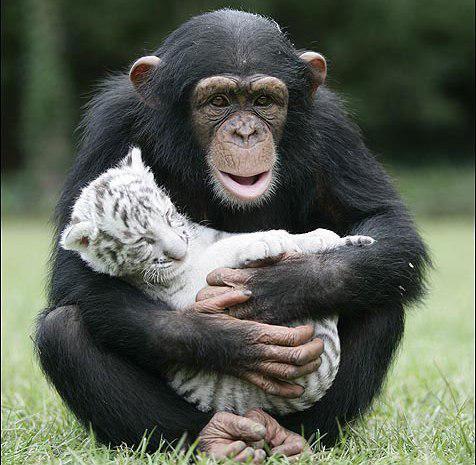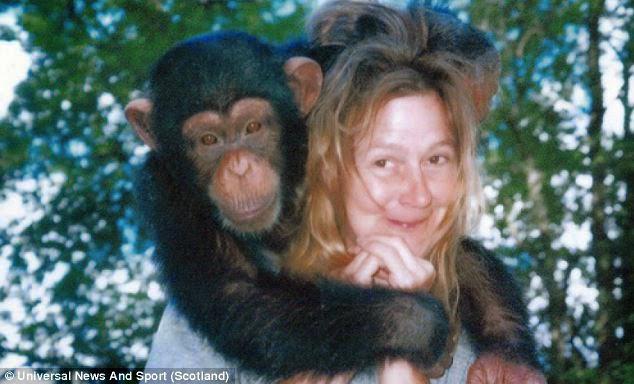The first image is the image on the left, the second image is the image on the right. For the images shown, is this caption "An ape is holding a baby white tiger." true? Answer yes or no. Yes. The first image is the image on the left, the second image is the image on the right. Evaluate the accuracy of this statement regarding the images: "there is a person in the image on the right". Is it true? Answer yes or no. Yes. 